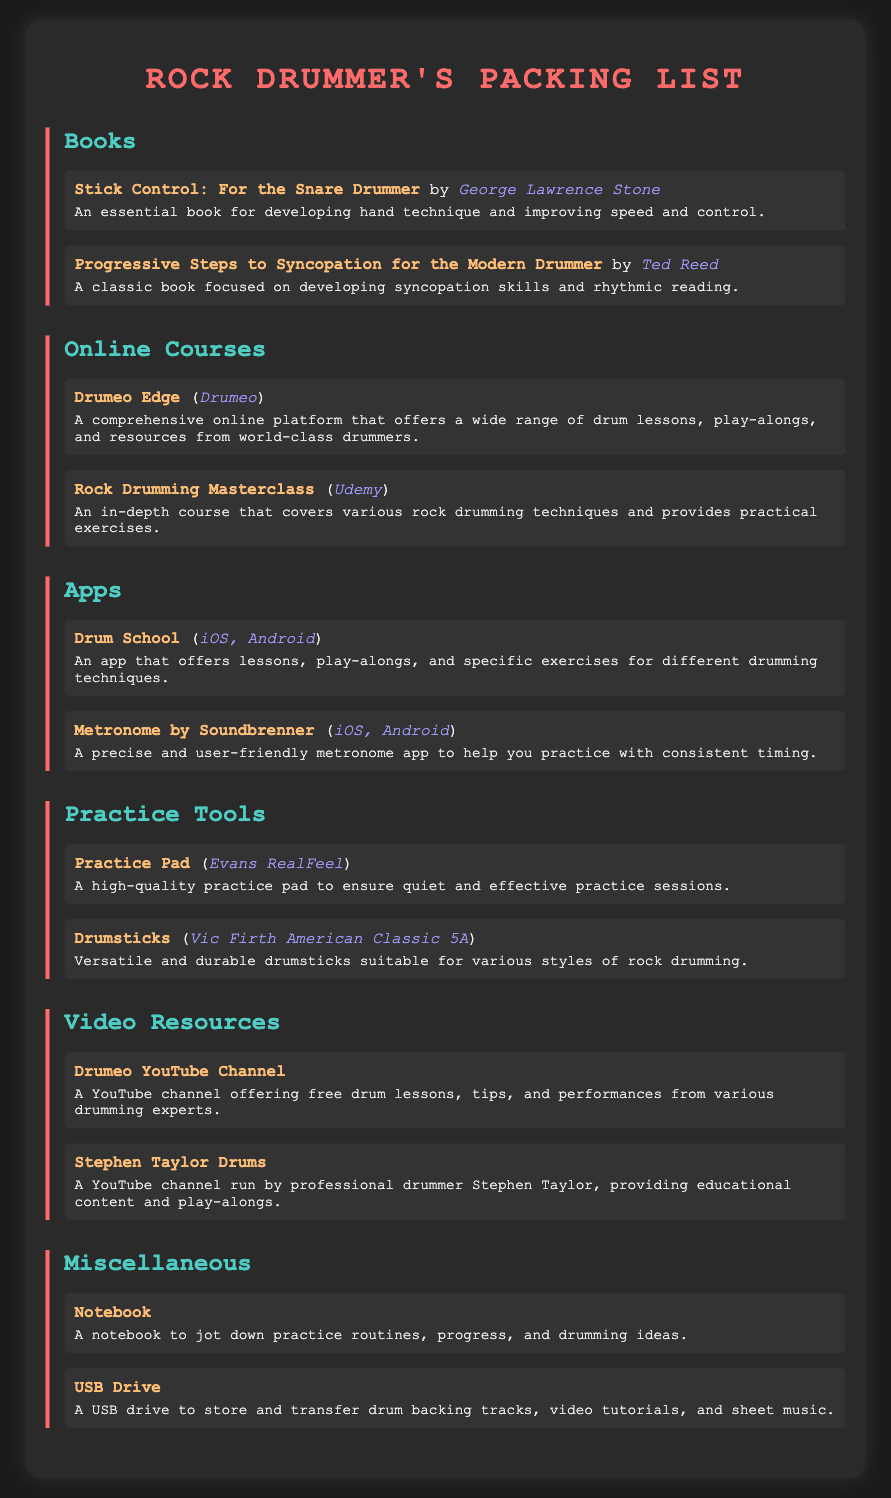What is the title of the first book listed? The title of the first book is "Stick Control: For the Snare Drummer," which is mentioned in the Books section.
Answer: "Stick Control: For the Snare Drummer" Who is the author of "Progressive Steps to Syncopation for the Modern Drummer"? The author of this book is Ted Reed, which is specified in the Books section.
Answer: Ted Reed Which online platform offers "Drumeo Edge"? The online platform for "Drumeo Edge" is Drumeo, as stated in the Online Courses section.
Answer: Drumeo What type of device is the "Metronome by Soundbrenner" available on? It is available on iOS and Android, which is noted in the Apps section.
Answer: iOS, Android What is the purpose of the Practice Pad mentioned? The Practice Pad is used for ensuring quiet and effective practice sessions, as described in the Practice Tools section.
Answer: Quiet and effective practice sessions How many video resources are listed in the document? There are two video resources mentioned, which are detailed in the Video Resources section.
Answer: Two What is the description of the "Notebook"? The description states that it is used to jot down practice routines, progress, and drumming ideas.
Answer: Jot down practice routines, progress, and drumming ideas Which item is associated with Vic Firth? The item associated with Vic Firth is "Drumsticks," as indicated in the Practice Tools section.
Answer: Drumsticks What distinguishes the section "Miscellaneous" from the others? The "Miscellaneous" section includes various items that don't fit into the other categories, such as a Notebook and USB Drive.
Answer: Various items that don't fit into the other categories 